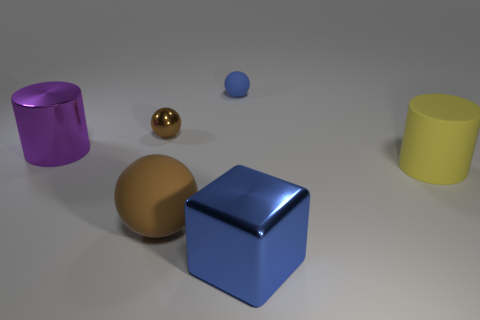There is a blue metallic block; does it have the same size as the cylinder that is to the left of the big yellow rubber object?
Ensure brevity in your answer.  Yes. There is a metallic object that is on the right side of the blue thing that is behind the big brown sphere; what size is it?
Ensure brevity in your answer.  Large. What number of large purple objects have the same material as the large yellow object?
Keep it short and to the point. 0. Is there a big green matte ball?
Give a very brief answer. No. What is the size of the brown object that is in front of the brown metallic object?
Provide a succinct answer. Large. What number of metal objects have the same color as the matte cylinder?
Your response must be concise. 0. What number of blocks are either matte things or large yellow rubber things?
Make the answer very short. 0. There is a big object that is both left of the big cube and on the right side of the tiny metallic thing; what shape is it?
Provide a short and direct response. Sphere. Are there any other brown balls that have the same size as the brown matte ball?
Your response must be concise. No. What number of objects are big matte things that are to the left of the yellow matte cylinder or large purple cylinders?
Provide a short and direct response. 2. 